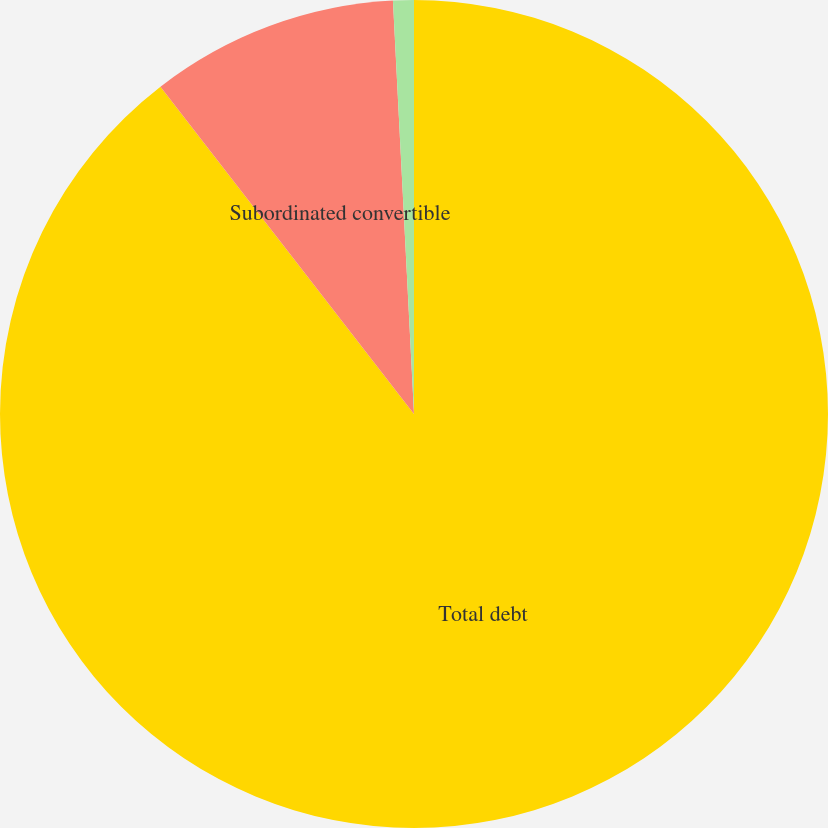<chart> <loc_0><loc_0><loc_500><loc_500><pie_chart><fcel>Total debt<fcel>Subordinated convertible<fcel>Stockholders' equity (deficit)<nl><fcel>89.51%<fcel>9.68%<fcel>0.81%<nl></chart> 